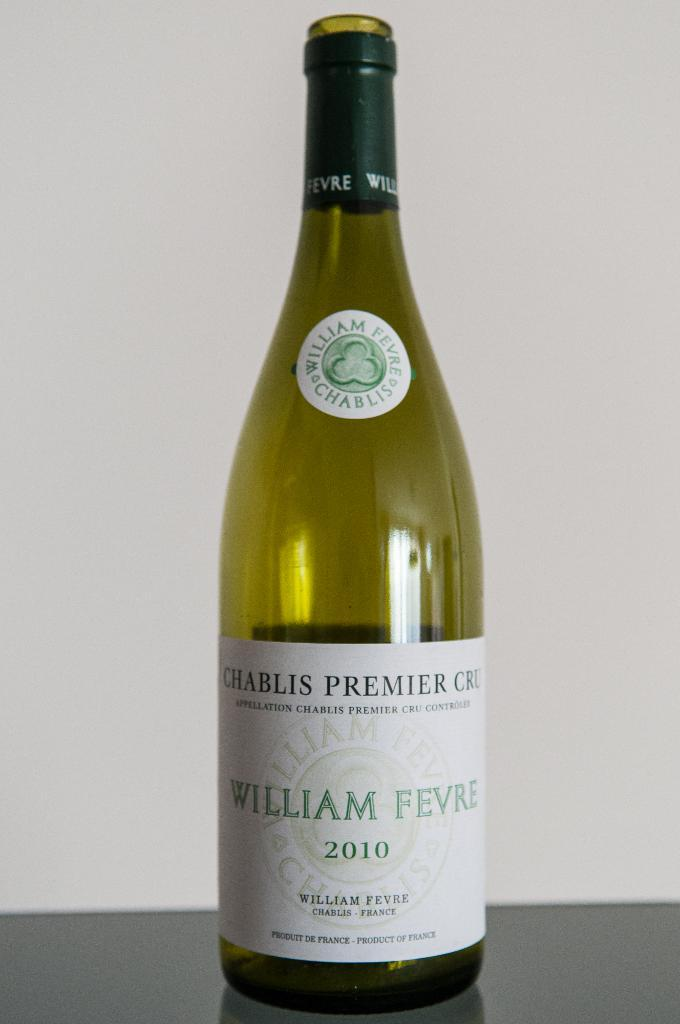<image>
Summarize the visual content of the image. A bottle of William Fevre 2010 sits on display 